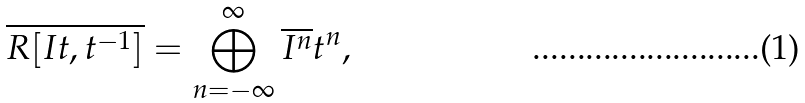<formula> <loc_0><loc_0><loc_500><loc_500>\overline { R [ I t , t ^ { - 1 } ] } = \bigoplus _ { n = - \infty } ^ { \infty } \overline { I ^ { n } } t ^ { n } ,</formula> 